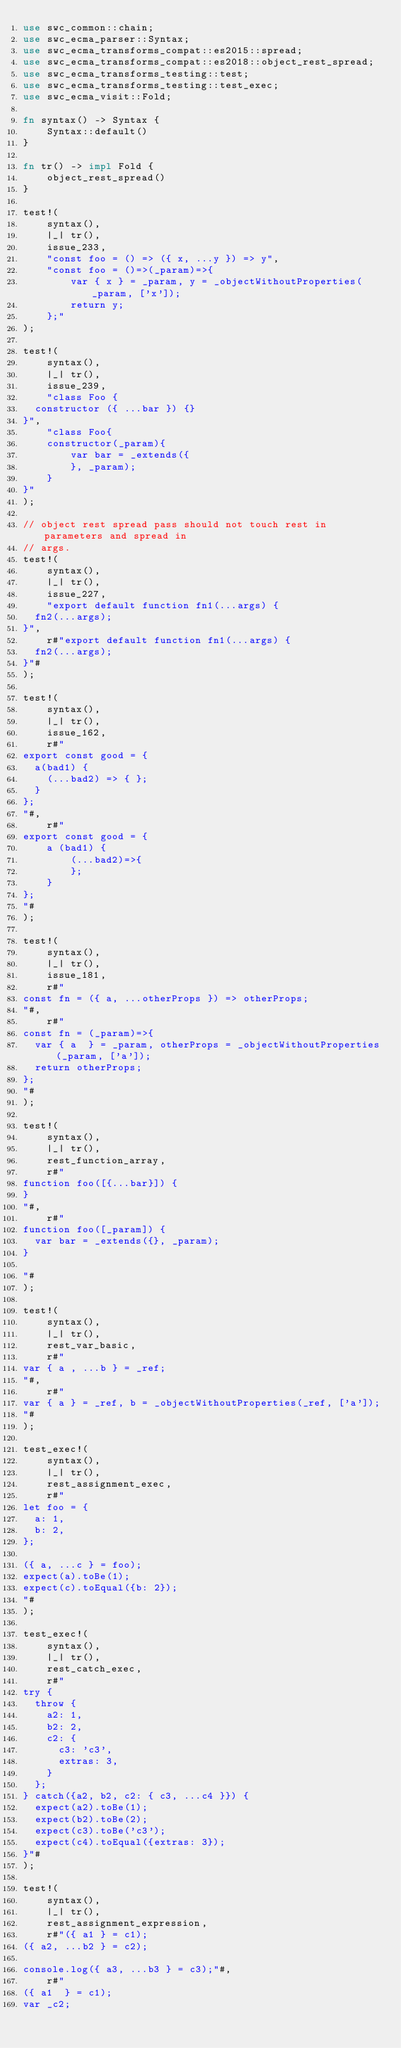Convert code to text. <code><loc_0><loc_0><loc_500><loc_500><_Rust_>use swc_common::chain;
use swc_ecma_parser::Syntax;
use swc_ecma_transforms_compat::es2015::spread;
use swc_ecma_transforms_compat::es2018::object_rest_spread;
use swc_ecma_transforms_testing::test;
use swc_ecma_transforms_testing::test_exec;
use swc_ecma_visit::Fold;

fn syntax() -> Syntax {
    Syntax::default()
}

fn tr() -> impl Fold {
    object_rest_spread()
}

test!(
    syntax(),
    |_| tr(),
    issue_233,
    "const foo = () => ({ x, ...y }) => y",
    "const foo = ()=>(_param)=>{
        var { x } = _param, y = _objectWithoutProperties(_param, ['x']);
        return y;
    };"
);

test!(
    syntax(),
    |_| tr(),
    issue_239,
    "class Foo {
  constructor ({ ...bar }) {}
}",
    "class Foo{
    constructor(_param){
        var bar = _extends({
        }, _param);
    }
}"
);

// object rest spread pass should not touch rest in parameters and spread in
// args.
test!(
    syntax(),
    |_| tr(),
    issue_227,
    "export default function fn1(...args) {
  fn2(...args);
}",
    r#"export default function fn1(...args) {
  fn2(...args);
}"#
);

test!(
    syntax(),
    |_| tr(),
    issue_162,
    r#"
export const good = {
  a(bad1) {
    (...bad2) => { };
  }
};
"#,
    r#"
export const good = {
    a (bad1) {
        (...bad2)=>{
        };
    }
};
"#
);

test!(
    syntax(),
    |_| tr(),
    issue_181,
    r#"
const fn = ({ a, ...otherProps }) => otherProps;
"#,
    r#"
const fn = (_param)=>{
  var { a  } = _param, otherProps = _objectWithoutProperties(_param, ['a']);
  return otherProps;
};
"#
);

test!(
    syntax(),
    |_| tr(),
    rest_function_array,
    r#"
function foo([{...bar}]) {
}
"#,
    r#"
function foo([_param]) {
  var bar = _extends({}, _param);
}

"#
);

test!(
    syntax(),
    |_| tr(),
    rest_var_basic,
    r#"
var { a , ...b } = _ref;
"#,
    r#"
var { a } = _ref, b = _objectWithoutProperties(_ref, ['a']);
"#
);

test_exec!(
    syntax(),
    |_| tr(),
    rest_assignment_exec,
    r#"
let foo = {
  a: 1,
  b: 2,
};

({ a, ...c } = foo);
expect(a).toBe(1);
expect(c).toEqual({b: 2});
"#
);

test_exec!(
    syntax(),
    |_| tr(),
    rest_catch_exec,
    r#"
try {
  throw {
    a2: 1,
    b2: 2,
    c2: {
      c3: 'c3',
      extras: 3,
    }
  };
} catch({a2, b2, c2: { c3, ...c4 }}) {
  expect(a2).toBe(1);
  expect(b2).toBe(2);
  expect(c3).toBe('c3');
  expect(c4).toEqual({extras: 3});
}"#
);

test!(
    syntax(),
    |_| tr(),
    rest_assignment_expression,
    r#"({ a1 } = c1);
({ a2, ...b2 } = c2);

console.log({ a3, ...b3 } = c3);"#,
    r#"
({ a1  } = c1);
var _c2;</code> 